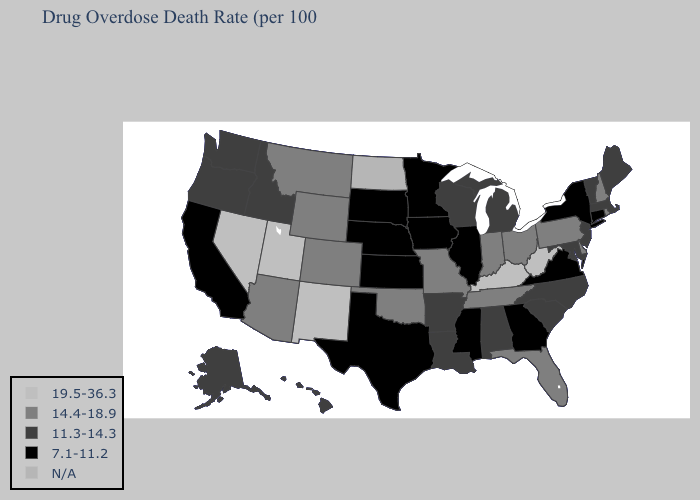Which states hav the highest value in the West?
Quick response, please. Nevada, New Mexico, Utah. Does New Jersey have the lowest value in the Northeast?
Write a very short answer. No. Name the states that have a value in the range 7.1-11.2?
Keep it brief. California, Connecticut, Georgia, Illinois, Iowa, Kansas, Minnesota, Mississippi, Nebraska, New York, South Dakota, Texas, Virginia. Name the states that have a value in the range 7.1-11.2?
Write a very short answer. California, Connecticut, Georgia, Illinois, Iowa, Kansas, Minnesota, Mississippi, Nebraska, New York, South Dakota, Texas, Virginia. What is the highest value in states that border Georgia?
Write a very short answer. 14.4-18.9. Name the states that have a value in the range 7.1-11.2?
Answer briefly. California, Connecticut, Georgia, Illinois, Iowa, Kansas, Minnesota, Mississippi, Nebraska, New York, South Dakota, Texas, Virginia. What is the value of Minnesota?
Concise answer only. 7.1-11.2. Which states hav the highest value in the MidWest?
Keep it brief. Indiana, Missouri, Ohio. What is the value of South Dakota?
Give a very brief answer. 7.1-11.2. What is the value of Delaware?
Quick response, please. 14.4-18.9. Name the states that have a value in the range N/A?
Quick response, please. North Dakota. Among the states that border New York , does Vermont have the highest value?
Short answer required. No. Does Florida have the highest value in the USA?
Short answer required. No. 